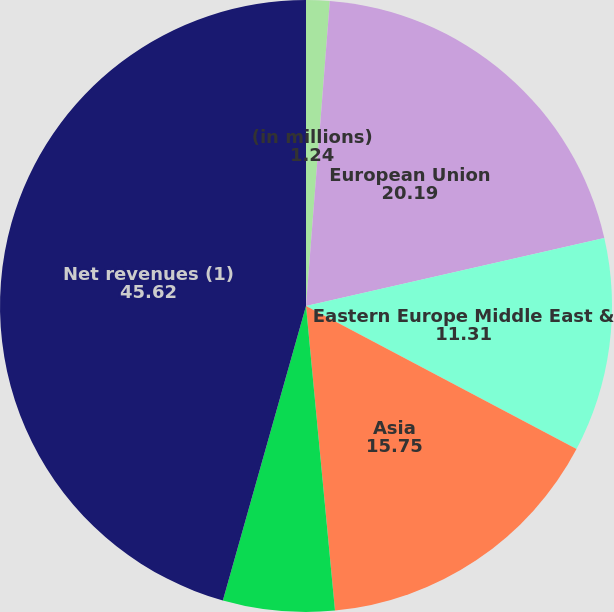Convert chart. <chart><loc_0><loc_0><loc_500><loc_500><pie_chart><fcel>(in millions)<fcel>European Union<fcel>Eastern Europe Middle East &<fcel>Asia<fcel>Latin America & Canada<fcel>Net revenues (1)<nl><fcel>1.24%<fcel>20.19%<fcel>11.31%<fcel>15.75%<fcel>5.89%<fcel>45.62%<nl></chart> 